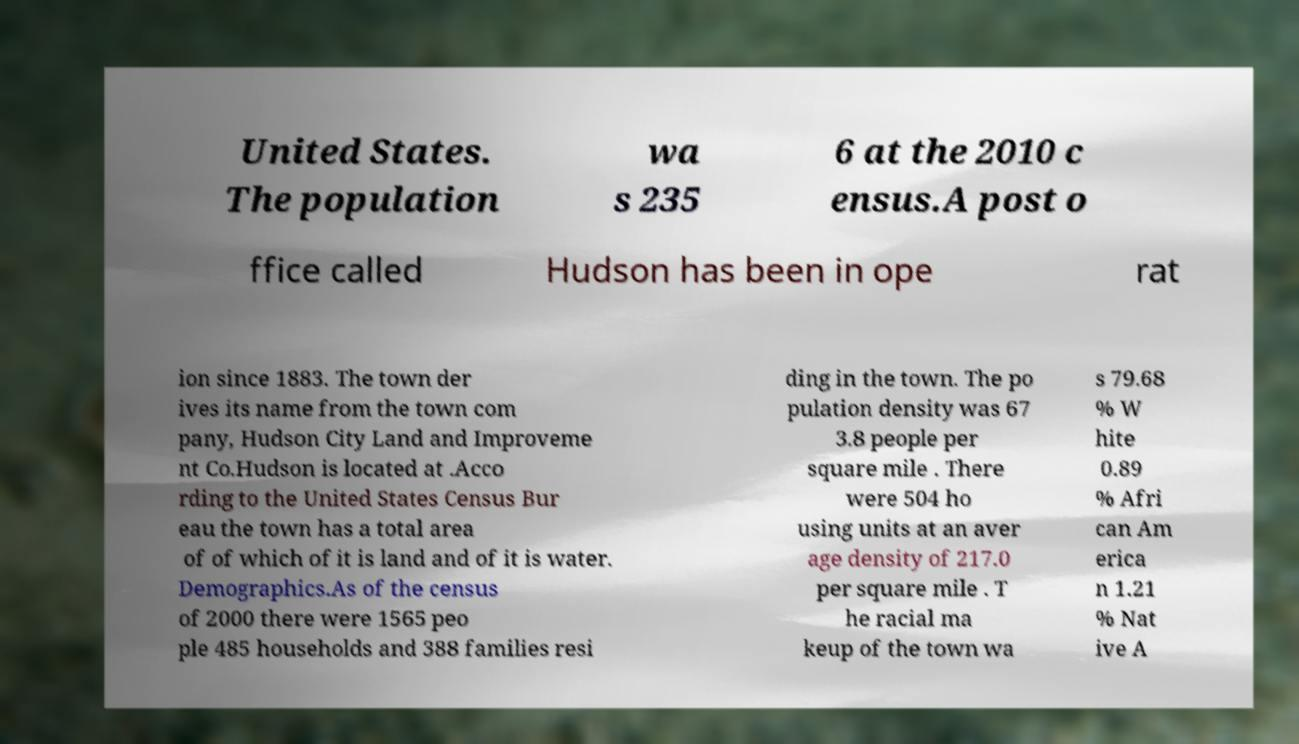What messages or text are displayed in this image? I need them in a readable, typed format. United States. The population wa s 235 6 at the 2010 c ensus.A post o ffice called Hudson has been in ope rat ion since 1883. The town der ives its name from the town com pany, Hudson City Land and Improveme nt Co.Hudson is located at .Acco rding to the United States Census Bur eau the town has a total area of of which of it is land and of it is water. Demographics.As of the census of 2000 there were 1565 peo ple 485 households and 388 families resi ding in the town. The po pulation density was 67 3.8 people per square mile . There were 504 ho using units at an aver age density of 217.0 per square mile . T he racial ma keup of the town wa s 79.68 % W hite 0.89 % Afri can Am erica n 1.21 % Nat ive A 